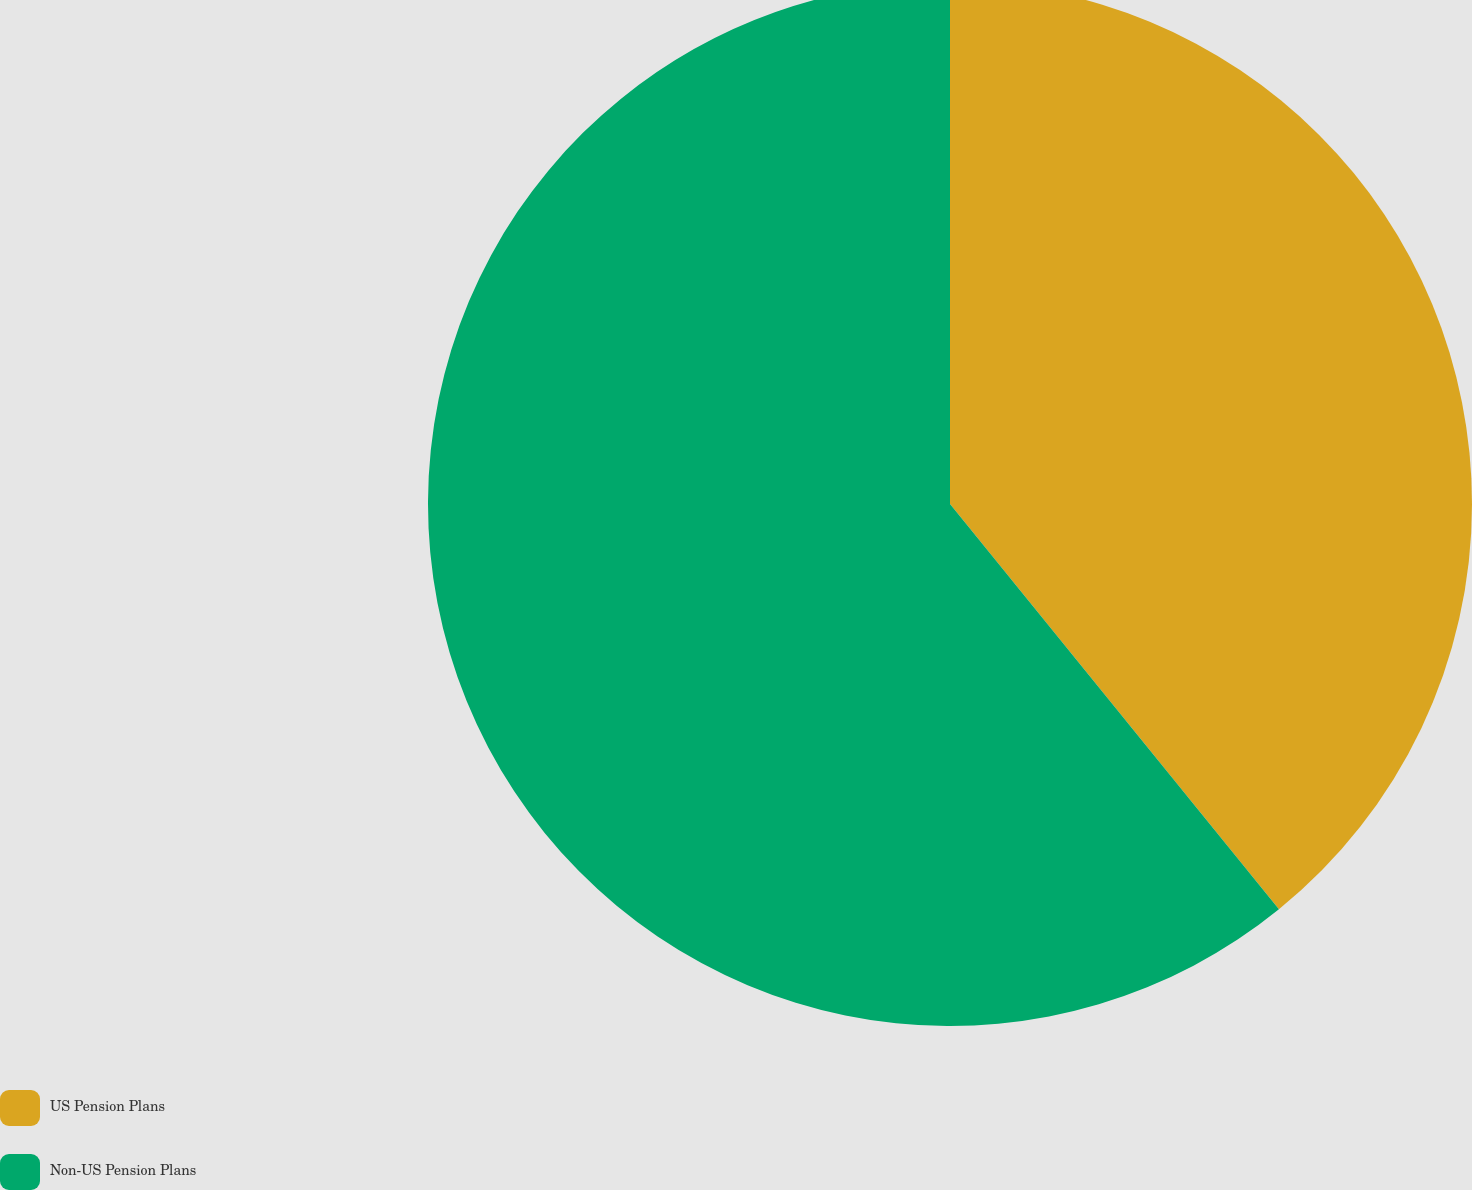Convert chart. <chart><loc_0><loc_0><loc_500><loc_500><pie_chart><fcel>US Pension Plans<fcel>Non-US Pension Plans<nl><fcel>39.15%<fcel>60.85%<nl></chart> 